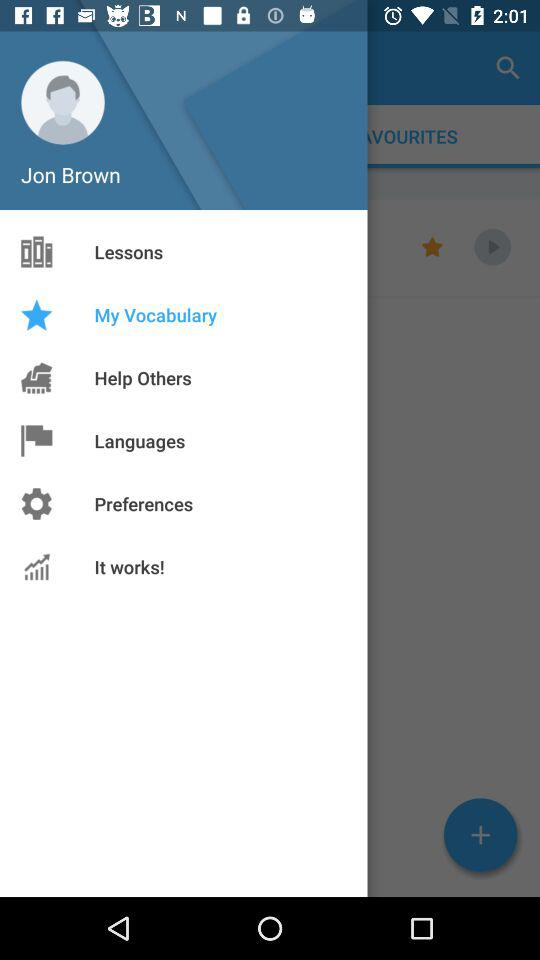What is the user profile name? The user profile name is Jon Brown. 